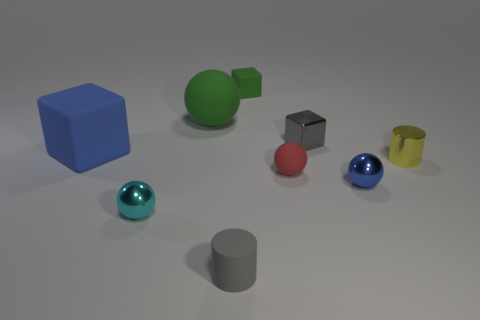Subtract all small blocks. How many blocks are left? 1 Add 1 big blue matte spheres. How many objects exist? 10 Subtract all blue blocks. How many blocks are left? 2 Subtract all blocks. How many objects are left? 6 Subtract 2 cylinders. How many cylinders are left? 0 Subtract 0 cyan cylinders. How many objects are left? 9 Subtract all purple blocks. Subtract all red cylinders. How many blocks are left? 3 Subtract all cyan cylinders. How many red spheres are left? 1 Subtract all tiny blue objects. Subtract all blue metallic things. How many objects are left? 7 Add 3 small gray matte things. How many small gray matte things are left? 4 